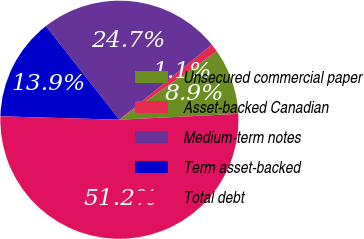Convert chart to OTSL. <chart><loc_0><loc_0><loc_500><loc_500><pie_chart><fcel>Unsecured commercial paper<fcel>Asset-backed Canadian<fcel>Medium-term notes<fcel>Term asset-backed<fcel>Total debt<nl><fcel>8.94%<fcel>1.14%<fcel>24.73%<fcel>13.95%<fcel>51.25%<nl></chart> 